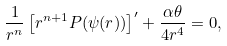<formula> <loc_0><loc_0><loc_500><loc_500>\frac { 1 } { r ^ { n } } \left [ r ^ { n + 1 } P ( \psi ( r ) ) \right ] ^ { \prime } + \frac { \alpha \theta } { 4 r ^ { 4 } } = 0 ,</formula> 